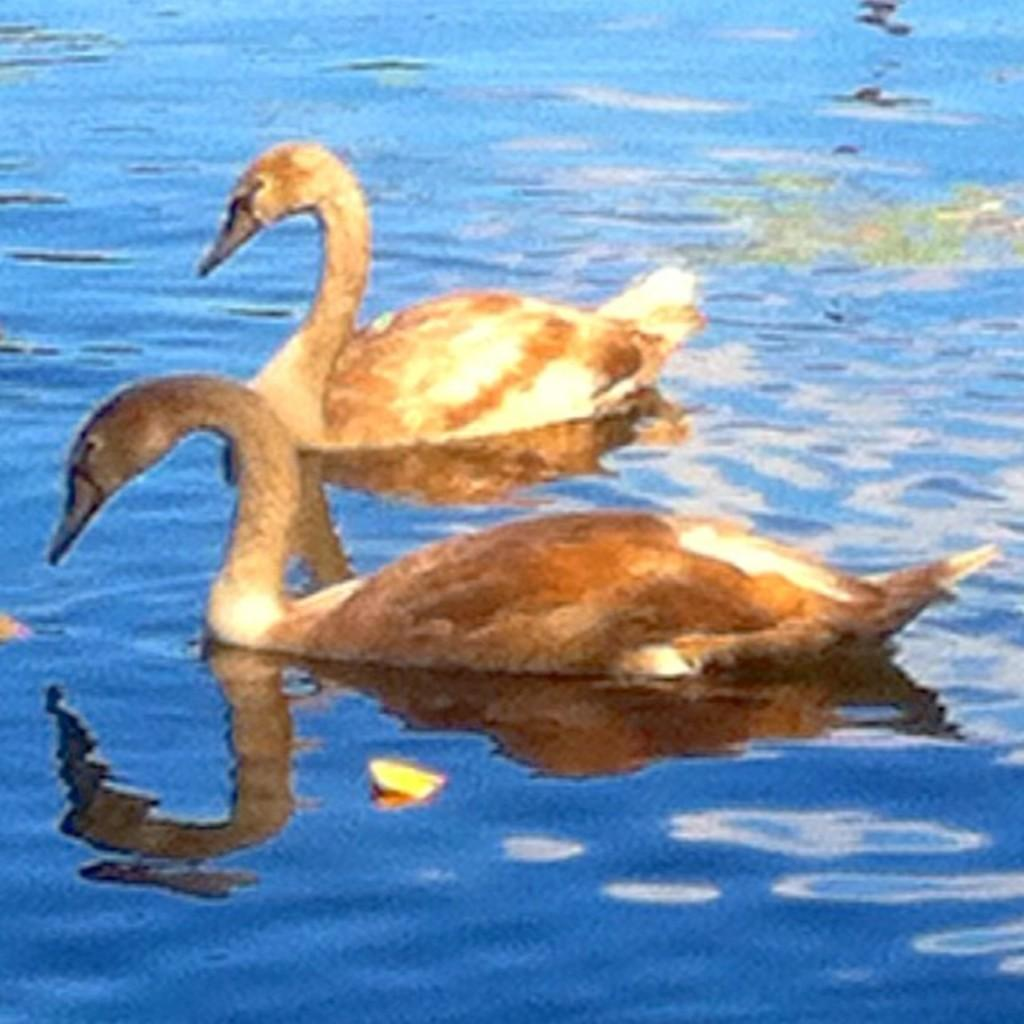How many birds are present in the image? There are two birds in the image. What colors are the birds? The birds are in brown and cream color. What is the color of the water in the image? The water in the image is blue. What type of gun can be seen in the image? There is no gun present in the image; it features two birds and blue water. 